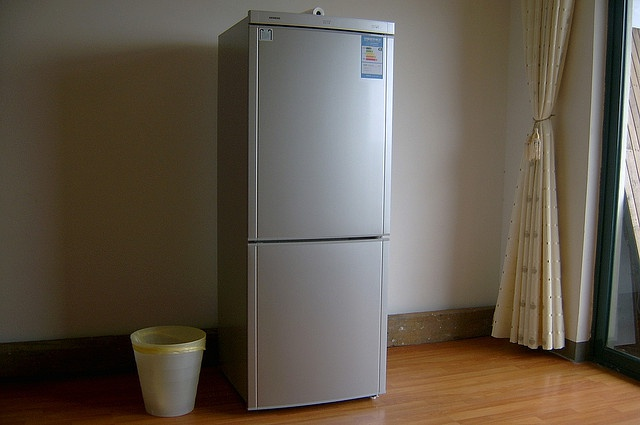Describe the objects in this image and their specific colors. I can see a refrigerator in black, gray, darkgray, and lavender tones in this image. 